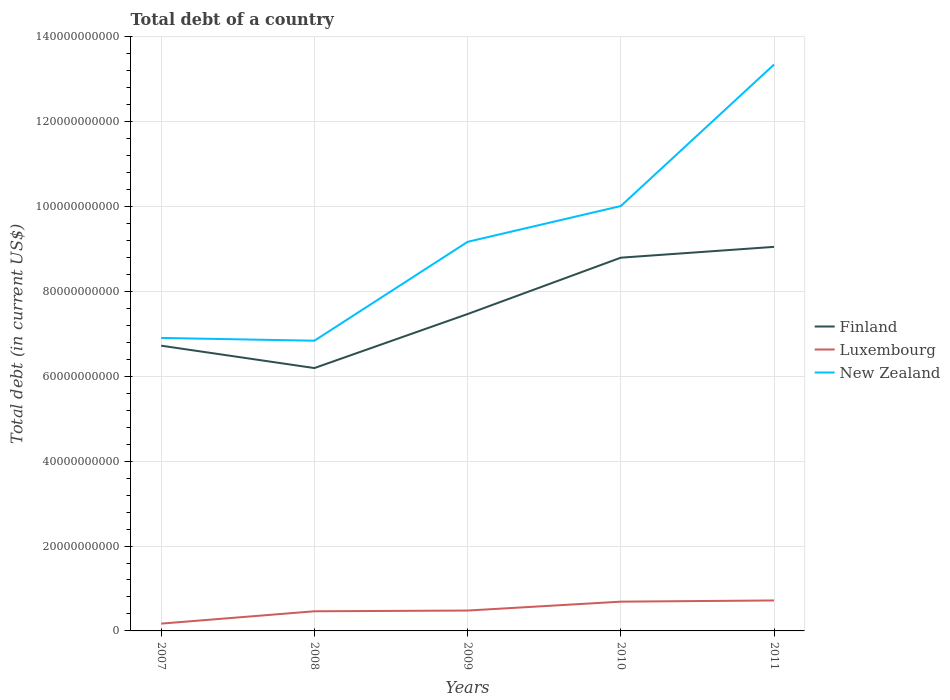How many different coloured lines are there?
Provide a short and direct response. 3. Does the line corresponding to Finland intersect with the line corresponding to Luxembourg?
Keep it short and to the point. No. Is the number of lines equal to the number of legend labels?
Give a very brief answer. Yes. Across all years, what is the maximum debt in Luxembourg?
Provide a succinct answer. 1.72e+09. In which year was the debt in Finland maximum?
Your response must be concise. 2008. What is the total debt in Finland in the graph?
Provide a short and direct response. -1.33e+1. What is the difference between the highest and the second highest debt in Luxembourg?
Your answer should be compact. 5.46e+09. What is the difference between the highest and the lowest debt in Luxembourg?
Provide a succinct answer. 2. How many years are there in the graph?
Keep it short and to the point. 5. What is the difference between two consecutive major ticks on the Y-axis?
Keep it short and to the point. 2.00e+1. Does the graph contain any zero values?
Provide a succinct answer. No. How many legend labels are there?
Give a very brief answer. 3. What is the title of the graph?
Ensure brevity in your answer.  Total debt of a country. Does "United States" appear as one of the legend labels in the graph?
Provide a succinct answer. No. What is the label or title of the X-axis?
Offer a very short reply. Years. What is the label or title of the Y-axis?
Your answer should be very brief. Total debt (in current US$). What is the Total debt (in current US$) of Finland in 2007?
Your answer should be compact. 6.72e+1. What is the Total debt (in current US$) in Luxembourg in 2007?
Make the answer very short. 1.72e+09. What is the Total debt (in current US$) of New Zealand in 2007?
Ensure brevity in your answer.  6.90e+1. What is the Total debt (in current US$) of Finland in 2008?
Make the answer very short. 6.19e+1. What is the Total debt (in current US$) of Luxembourg in 2008?
Provide a short and direct response. 4.63e+09. What is the Total debt (in current US$) of New Zealand in 2008?
Offer a very short reply. 6.84e+1. What is the Total debt (in current US$) of Finland in 2009?
Offer a very short reply. 7.47e+1. What is the Total debt (in current US$) in Luxembourg in 2009?
Your answer should be compact. 4.80e+09. What is the Total debt (in current US$) of New Zealand in 2009?
Your answer should be very brief. 9.17e+1. What is the Total debt (in current US$) of Finland in 2010?
Offer a terse response. 8.79e+1. What is the Total debt (in current US$) of Luxembourg in 2010?
Make the answer very short. 6.89e+09. What is the Total debt (in current US$) in New Zealand in 2010?
Provide a short and direct response. 1.00e+11. What is the Total debt (in current US$) in Finland in 2011?
Your response must be concise. 9.05e+1. What is the Total debt (in current US$) of Luxembourg in 2011?
Offer a very short reply. 7.18e+09. What is the Total debt (in current US$) of New Zealand in 2011?
Make the answer very short. 1.33e+11. Across all years, what is the maximum Total debt (in current US$) of Finland?
Give a very brief answer. 9.05e+1. Across all years, what is the maximum Total debt (in current US$) of Luxembourg?
Your response must be concise. 7.18e+09. Across all years, what is the maximum Total debt (in current US$) in New Zealand?
Provide a short and direct response. 1.33e+11. Across all years, what is the minimum Total debt (in current US$) of Finland?
Your answer should be very brief. 6.19e+1. Across all years, what is the minimum Total debt (in current US$) in Luxembourg?
Keep it short and to the point. 1.72e+09. Across all years, what is the minimum Total debt (in current US$) in New Zealand?
Your answer should be very brief. 6.84e+1. What is the total Total debt (in current US$) in Finland in the graph?
Your answer should be compact. 3.82e+11. What is the total Total debt (in current US$) of Luxembourg in the graph?
Offer a terse response. 2.52e+1. What is the total Total debt (in current US$) in New Zealand in the graph?
Offer a very short reply. 4.63e+11. What is the difference between the Total debt (in current US$) of Finland in 2007 and that in 2008?
Your answer should be very brief. 5.27e+09. What is the difference between the Total debt (in current US$) in Luxembourg in 2007 and that in 2008?
Your answer should be very brief. -2.91e+09. What is the difference between the Total debt (in current US$) of New Zealand in 2007 and that in 2008?
Your answer should be compact. 6.55e+08. What is the difference between the Total debt (in current US$) of Finland in 2007 and that in 2009?
Offer a terse response. -7.46e+09. What is the difference between the Total debt (in current US$) in Luxembourg in 2007 and that in 2009?
Make the answer very short. -3.08e+09. What is the difference between the Total debt (in current US$) of New Zealand in 2007 and that in 2009?
Your answer should be compact. -2.26e+1. What is the difference between the Total debt (in current US$) of Finland in 2007 and that in 2010?
Make the answer very short. -2.07e+1. What is the difference between the Total debt (in current US$) of Luxembourg in 2007 and that in 2010?
Give a very brief answer. -5.17e+09. What is the difference between the Total debt (in current US$) in New Zealand in 2007 and that in 2010?
Provide a short and direct response. -3.11e+1. What is the difference between the Total debt (in current US$) of Finland in 2007 and that in 2011?
Offer a very short reply. -2.33e+1. What is the difference between the Total debt (in current US$) of Luxembourg in 2007 and that in 2011?
Your answer should be compact. -5.46e+09. What is the difference between the Total debt (in current US$) of New Zealand in 2007 and that in 2011?
Your answer should be compact. -6.44e+1. What is the difference between the Total debt (in current US$) of Finland in 2008 and that in 2009?
Provide a short and direct response. -1.27e+1. What is the difference between the Total debt (in current US$) of Luxembourg in 2008 and that in 2009?
Your response must be concise. -1.70e+08. What is the difference between the Total debt (in current US$) in New Zealand in 2008 and that in 2009?
Offer a terse response. -2.33e+1. What is the difference between the Total debt (in current US$) of Finland in 2008 and that in 2010?
Ensure brevity in your answer.  -2.60e+1. What is the difference between the Total debt (in current US$) in Luxembourg in 2008 and that in 2010?
Make the answer very short. -2.27e+09. What is the difference between the Total debt (in current US$) of New Zealand in 2008 and that in 2010?
Your answer should be very brief. -3.17e+1. What is the difference between the Total debt (in current US$) of Finland in 2008 and that in 2011?
Your response must be concise. -2.86e+1. What is the difference between the Total debt (in current US$) in Luxembourg in 2008 and that in 2011?
Offer a very short reply. -2.55e+09. What is the difference between the Total debt (in current US$) of New Zealand in 2008 and that in 2011?
Make the answer very short. -6.51e+1. What is the difference between the Total debt (in current US$) of Finland in 2009 and that in 2010?
Your response must be concise. -1.33e+1. What is the difference between the Total debt (in current US$) in Luxembourg in 2009 and that in 2010?
Offer a terse response. -2.10e+09. What is the difference between the Total debt (in current US$) in New Zealand in 2009 and that in 2010?
Give a very brief answer. -8.43e+09. What is the difference between the Total debt (in current US$) of Finland in 2009 and that in 2011?
Your answer should be very brief. -1.58e+1. What is the difference between the Total debt (in current US$) of Luxembourg in 2009 and that in 2011?
Provide a succinct answer. -2.38e+09. What is the difference between the Total debt (in current US$) in New Zealand in 2009 and that in 2011?
Ensure brevity in your answer.  -4.18e+1. What is the difference between the Total debt (in current US$) of Finland in 2010 and that in 2011?
Keep it short and to the point. -2.55e+09. What is the difference between the Total debt (in current US$) of Luxembourg in 2010 and that in 2011?
Give a very brief answer. -2.83e+08. What is the difference between the Total debt (in current US$) of New Zealand in 2010 and that in 2011?
Keep it short and to the point. -3.33e+1. What is the difference between the Total debt (in current US$) of Finland in 2007 and the Total debt (in current US$) of Luxembourg in 2008?
Your answer should be very brief. 6.26e+1. What is the difference between the Total debt (in current US$) of Finland in 2007 and the Total debt (in current US$) of New Zealand in 2008?
Your answer should be compact. -1.17e+09. What is the difference between the Total debt (in current US$) of Luxembourg in 2007 and the Total debt (in current US$) of New Zealand in 2008?
Provide a short and direct response. -6.66e+1. What is the difference between the Total debt (in current US$) in Finland in 2007 and the Total debt (in current US$) in Luxembourg in 2009?
Offer a very short reply. 6.24e+1. What is the difference between the Total debt (in current US$) of Finland in 2007 and the Total debt (in current US$) of New Zealand in 2009?
Make the answer very short. -2.45e+1. What is the difference between the Total debt (in current US$) of Luxembourg in 2007 and the Total debt (in current US$) of New Zealand in 2009?
Your answer should be very brief. -8.99e+1. What is the difference between the Total debt (in current US$) of Finland in 2007 and the Total debt (in current US$) of Luxembourg in 2010?
Provide a short and direct response. 6.03e+1. What is the difference between the Total debt (in current US$) in Finland in 2007 and the Total debt (in current US$) in New Zealand in 2010?
Offer a terse response. -3.29e+1. What is the difference between the Total debt (in current US$) of Luxembourg in 2007 and the Total debt (in current US$) of New Zealand in 2010?
Keep it short and to the point. -9.84e+1. What is the difference between the Total debt (in current US$) of Finland in 2007 and the Total debt (in current US$) of Luxembourg in 2011?
Your answer should be compact. 6.00e+1. What is the difference between the Total debt (in current US$) of Finland in 2007 and the Total debt (in current US$) of New Zealand in 2011?
Ensure brevity in your answer.  -6.62e+1. What is the difference between the Total debt (in current US$) in Luxembourg in 2007 and the Total debt (in current US$) in New Zealand in 2011?
Give a very brief answer. -1.32e+11. What is the difference between the Total debt (in current US$) in Finland in 2008 and the Total debt (in current US$) in Luxembourg in 2009?
Your answer should be very brief. 5.71e+1. What is the difference between the Total debt (in current US$) in Finland in 2008 and the Total debt (in current US$) in New Zealand in 2009?
Make the answer very short. -2.97e+1. What is the difference between the Total debt (in current US$) in Luxembourg in 2008 and the Total debt (in current US$) in New Zealand in 2009?
Provide a short and direct response. -8.70e+1. What is the difference between the Total debt (in current US$) of Finland in 2008 and the Total debt (in current US$) of Luxembourg in 2010?
Ensure brevity in your answer.  5.50e+1. What is the difference between the Total debt (in current US$) in Finland in 2008 and the Total debt (in current US$) in New Zealand in 2010?
Provide a short and direct response. -3.82e+1. What is the difference between the Total debt (in current US$) in Luxembourg in 2008 and the Total debt (in current US$) in New Zealand in 2010?
Your answer should be very brief. -9.55e+1. What is the difference between the Total debt (in current US$) of Finland in 2008 and the Total debt (in current US$) of Luxembourg in 2011?
Make the answer very short. 5.47e+1. What is the difference between the Total debt (in current US$) of Finland in 2008 and the Total debt (in current US$) of New Zealand in 2011?
Give a very brief answer. -7.15e+1. What is the difference between the Total debt (in current US$) of Luxembourg in 2008 and the Total debt (in current US$) of New Zealand in 2011?
Offer a very short reply. -1.29e+11. What is the difference between the Total debt (in current US$) of Finland in 2009 and the Total debt (in current US$) of Luxembourg in 2010?
Ensure brevity in your answer.  6.78e+1. What is the difference between the Total debt (in current US$) in Finland in 2009 and the Total debt (in current US$) in New Zealand in 2010?
Make the answer very short. -2.54e+1. What is the difference between the Total debt (in current US$) in Luxembourg in 2009 and the Total debt (in current US$) in New Zealand in 2010?
Your answer should be compact. -9.53e+1. What is the difference between the Total debt (in current US$) in Finland in 2009 and the Total debt (in current US$) in Luxembourg in 2011?
Your response must be concise. 6.75e+1. What is the difference between the Total debt (in current US$) of Finland in 2009 and the Total debt (in current US$) of New Zealand in 2011?
Your response must be concise. -5.88e+1. What is the difference between the Total debt (in current US$) in Luxembourg in 2009 and the Total debt (in current US$) in New Zealand in 2011?
Provide a succinct answer. -1.29e+11. What is the difference between the Total debt (in current US$) of Finland in 2010 and the Total debt (in current US$) of Luxembourg in 2011?
Ensure brevity in your answer.  8.08e+1. What is the difference between the Total debt (in current US$) of Finland in 2010 and the Total debt (in current US$) of New Zealand in 2011?
Make the answer very short. -4.55e+1. What is the difference between the Total debt (in current US$) of Luxembourg in 2010 and the Total debt (in current US$) of New Zealand in 2011?
Your answer should be very brief. -1.27e+11. What is the average Total debt (in current US$) of Finland per year?
Make the answer very short. 7.64e+1. What is the average Total debt (in current US$) of Luxembourg per year?
Provide a short and direct response. 5.04e+09. What is the average Total debt (in current US$) of New Zealand per year?
Provide a short and direct response. 9.25e+1. In the year 2007, what is the difference between the Total debt (in current US$) of Finland and Total debt (in current US$) of Luxembourg?
Offer a terse response. 6.55e+1. In the year 2007, what is the difference between the Total debt (in current US$) in Finland and Total debt (in current US$) in New Zealand?
Give a very brief answer. -1.83e+09. In the year 2007, what is the difference between the Total debt (in current US$) of Luxembourg and Total debt (in current US$) of New Zealand?
Offer a terse response. -6.73e+1. In the year 2008, what is the difference between the Total debt (in current US$) of Finland and Total debt (in current US$) of Luxembourg?
Your response must be concise. 5.73e+1. In the year 2008, what is the difference between the Total debt (in current US$) in Finland and Total debt (in current US$) in New Zealand?
Your response must be concise. -6.44e+09. In the year 2008, what is the difference between the Total debt (in current US$) in Luxembourg and Total debt (in current US$) in New Zealand?
Make the answer very short. -6.37e+1. In the year 2009, what is the difference between the Total debt (in current US$) of Finland and Total debt (in current US$) of Luxembourg?
Give a very brief answer. 6.99e+1. In the year 2009, what is the difference between the Total debt (in current US$) of Finland and Total debt (in current US$) of New Zealand?
Make the answer very short. -1.70e+1. In the year 2009, what is the difference between the Total debt (in current US$) of Luxembourg and Total debt (in current US$) of New Zealand?
Ensure brevity in your answer.  -8.69e+1. In the year 2010, what is the difference between the Total debt (in current US$) in Finland and Total debt (in current US$) in Luxembourg?
Your answer should be very brief. 8.10e+1. In the year 2010, what is the difference between the Total debt (in current US$) of Finland and Total debt (in current US$) of New Zealand?
Provide a succinct answer. -1.22e+1. In the year 2010, what is the difference between the Total debt (in current US$) of Luxembourg and Total debt (in current US$) of New Zealand?
Provide a succinct answer. -9.32e+1. In the year 2011, what is the difference between the Total debt (in current US$) in Finland and Total debt (in current US$) in Luxembourg?
Make the answer very short. 8.33e+1. In the year 2011, what is the difference between the Total debt (in current US$) in Finland and Total debt (in current US$) in New Zealand?
Ensure brevity in your answer.  -4.30e+1. In the year 2011, what is the difference between the Total debt (in current US$) of Luxembourg and Total debt (in current US$) of New Zealand?
Ensure brevity in your answer.  -1.26e+11. What is the ratio of the Total debt (in current US$) of Finland in 2007 to that in 2008?
Keep it short and to the point. 1.09. What is the ratio of the Total debt (in current US$) in Luxembourg in 2007 to that in 2008?
Provide a short and direct response. 0.37. What is the ratio of the Total debt (in current US$) of New Zealand in 2007 to that in 2008?
Your response must be concise. 1.01. What is the ratio of the Total debt (in current US$) of Finland in 2007 to that in 2009?
Ensure brevity in your answer.  0.9. What is the ratio of the Total debt (in current US$) in Luxembourg in 2007 to that in 2009?
Keep it short and to the point. 0.36. What is the ratio of the Total debt (in current US$) in New Zealand in 2007 to that in 2009?
Your answer should be very brief. 0.75. What is the ratio of the Total debt (in current US$) of Finland in 2007 to that in 2010?
Keep it short and to the point. 0.76. What is the ratio of the Total debt (in current US$) in Luxembourg in 2007 to that in 2010?
Ensure brevity in your answer.  0.25. What is the ratio of the Total debt (in current US$) in New Zealand in 2007 to that in 2010?
Offer a very short reply. 0.69. What is the ratio of the Total debt (in current US$) of Finland in 2007 to that in 2011?
Provide a short and direct response. 0.74. What is the ratio of the Total debt (in current US$) of Luxembourg in 2007 to that in 2011?
Make the answer very short. 0.24. What is the ratio of the Total debt (in current US$) in New Zealand in 2007 to that in 2011?
Your answer should be compact. 0.52. What is the ratio of the Total debt (in current US$) in Finland in 2008 to that in 2009?
Provide a short and direct response. 0.83. What is the ratio of the Total debt (in current US$) in Luxembourg in 2008 to that in 2009?
Your answer should be very brief. 0.96. What is the ratio of the Total debt (in current US$) of New Zealand in 2008 to that in 2009?
Your answer should be compact. 0.75. What is the ratio of the Total debt (in current US$) in Finland in 2008 to that in 2010?
Provide a succinct answer. 0.7. What is the ratio of the Total debt (in current US$) in Luxembourg in 2008 to that in 2010?
Your response must be concise. 0.67. What is the ratio of the Total debt (in current US$) in New Zealand in 2008 to that in 2010?
Provide a succinct answer. 0.68. What is the ratio of the Total debt (in current US$) in Finland in 2008 to that in 2011?
Offer a very short reply. 0.68. What is the ratio of the Total debt (in current US$) of Luxembourg in 2008 to that in 2011?
Offer a terse response. 0.64. What is the ratio of the Total debt (in current US$) of New Zealand in 2008 to that in 2011?
Your response must be concise. 0.51. What is the ratio of the Total debt (in current US$) of Finland in 2009 to that in 2010?
Keep it short and to the point. 0.85. What is the ratio of the Total debt (in current US$) of Luxembourg in 2009 to that in 2010?
Ensure brevity in your answer.  0.7. What is the ratio of the Total debt (in current US$) of New Zealand in 2009 to that in 2010?
Offer a terse response. 0.92. What is the ratio of the Total debt (in current US$) of Finland in 2009 to that in 2011?
Make the answer very short. 0.83. What is the ratio of the Total debt (in current US$) in Luxembourg in 2009 to that in 2011?
Your answer should be compact. 0.67. What is the ratio of the Total debt (in current US$) of New Zealand in 2009 to that in 2011?
Provide a short and direct response. 0.69. What is the ratio of the Total debt (in current US$) in Finland in 2010 to that in 2011?
Offer a terse response. 0.97. What is the ratio of the Total debt (in current US$) in Luxembourg in 2010 to that in 2011?
Provide a short and direct response. 0.96. What is the ratio of the Total debt (in current US$) of New Zealand in 2010 to that in 2011?
Ensure brevity in your answer.  0.75. What is the difference between the highest and the second highest Total debt (in current US$) in Finland?
Give a very brief answer. 2.55e+09. What is the difference between the highest and the second highest Total debt (in current US$) of Luxembourg?
Your answer should be very brief. 2.83e+08. What is the difference between the highest and the second highest Total debt (in current US$) of New Zealand?
Offer a terse response. 3.33e+1. What is the difference between the highest and the lowest Total debt (in current US$) in Finland?
Your answer should be compact. 2.86e+1. What is the difference between the highest and the lowest Total debt (in current US$) of Luxembourg?
Keep it short and to the point. 5.46e+09. What is the difference between the highest and the lowest Total debt (in current US$) in New Zealand?
Your answer should be very brief. 6.51e+1. 